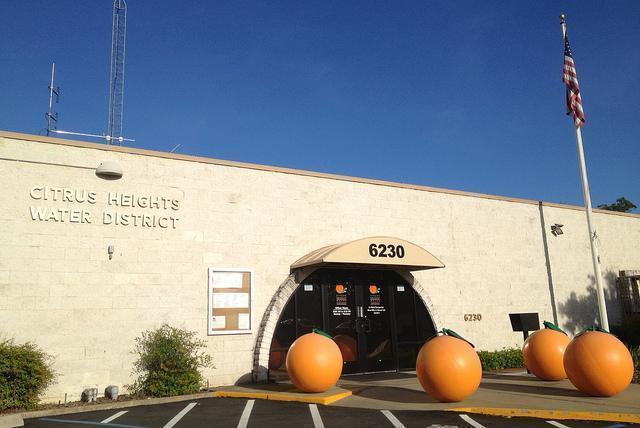What time in the morning does this building open to the public?
Make your selection from the four choices given to correctly answer the question.
Options: Nine, ten, 11, eight. Eight. 